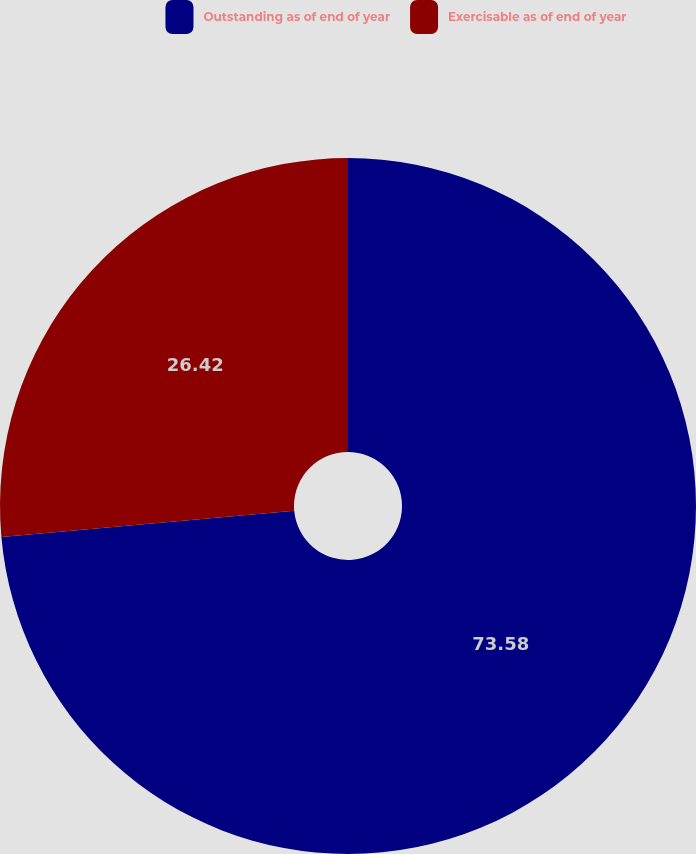Convert chart to OTSL. <chart><loc_0><loc_0><loc_500><loc_500><pie_chart><fcel>Outstanding as of end of year<fcel>Exercisable as of end of year<nl><fcel>73.58%<fcel>26.42%<nl></chart> 